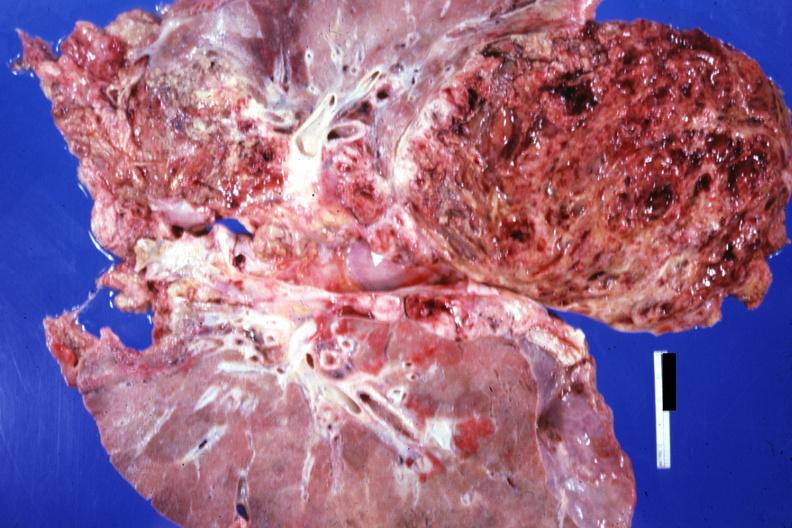what is present?
Answer the question using a single word or phrase. Thorax 